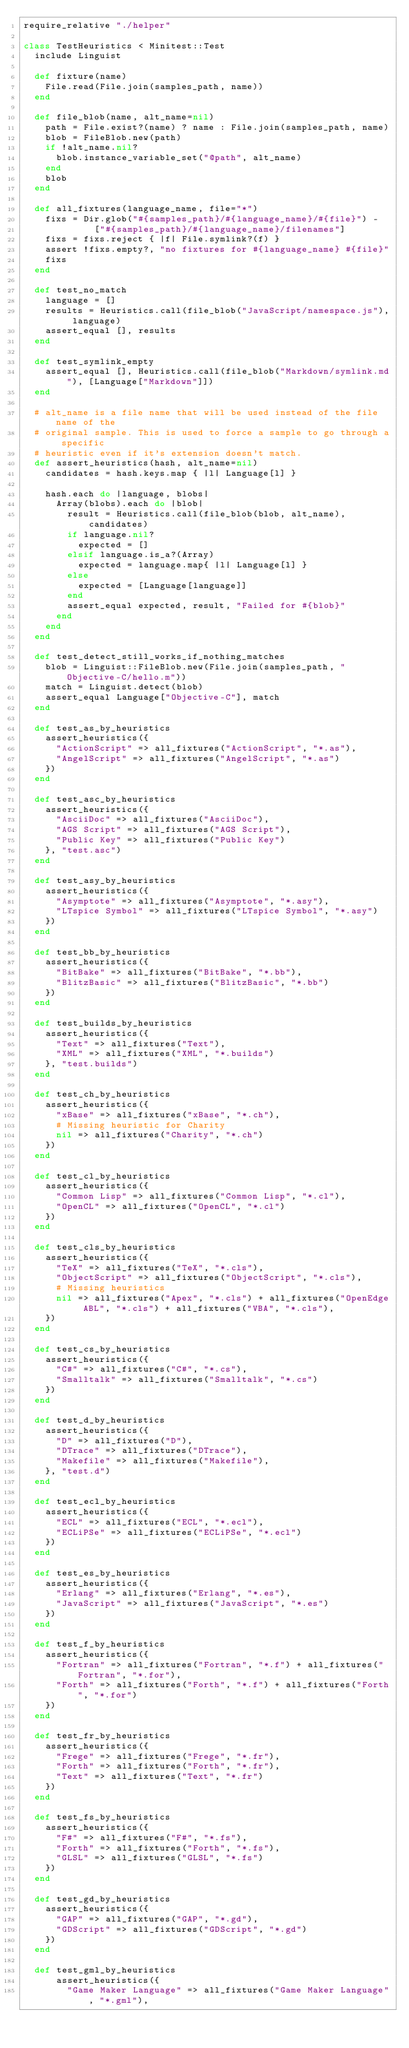Convert code to text. <code><loc_0><loc_0><loc_500><loc_500><_Ruby_>require_relative "./helper"

class TestHeuristics < Minitest::Test
  include Linguist

  def fixture(name)
    File.read(File.join(samples_path, name))
  end

  def file_blob(name, alt_name=nil)
    path = File.exist?(name) ? name : File.join(samples_path, name)
    blob = FileBlob.new(path)
    if !alt_name.nil?
      blob.instance_variable_set("@path", alt_name)
    end
    blob
  end

  def all_fixtures(language_name, file="*")
    fixs = Dir.glob("#{samples_path}/#{language_name}/#{file}") -
             ["#{samples_path}/#{language_name}/filenames"]
    fixs = fixs.reject { |f| File.symlink?(f) }
    assert !fixs.empty?, "no fixtures for #{language_name} #{file}"
    fixs
  end

  def test_no_match
    language = []
    results = Heuristics.call(file_blob("JavaScript/namespace.js"), language)
    assert_equal [], results
  end

  def test_symlink_empty
    assert_equal [], Heuristics.call(file_blob("Markdown/symlink.md"), [Language["Markdown"]])
  end

  # alt_name is a file name that will be used instead of the file name of the
  # original sample. This is used to force a sample to go through a specific
  # heuristic even if it's extension doesn't match.
  def assert_heuristics(hash, alt_name=nil)
    candidates = hash.keys.map { |l| Language[l] }

    hash.each do |language, blobs|
      Array(blobs).each do |blob|
        result = Heuristics.call(file_blob(blob, alt_name), candidates)
        if language.nil?
          expected = []
        elsif language.is_a?(Array)
          expected = language.map{ |l| Language[l] }
        else
          expected = [Language[language]]
        end
        assert_equal expected, result, "Failed for #{blob}"
      end
    end
  end

  def test_detect_still_works_if_nothing_matches
    blob = Linguist::FileBlob.new(File.join(samples_path, "Objective-C/hello.m"))
    match = Linguist.detect(blob)
    assert_equal Language["Objective-C"], match
  end

  def test_as_by_heuristics
    assert_heuristics({
      "ActionScript" => all_fixtures("ActionScript", "*.as"),
      "AngelScript" => all_fixtures("AngelScript", "*.as")
    })
  end

  def test_asc_by_heuristics
    assert_heuristics({
      "AsciiDoc" => all_fixtures("AsciiDoc"),
      "AGS Script" => all_fixtures("AGS Script"),
      "Public Key" => all_fixtures("Public Key")
    }, "test.asc")
  end

  def test_asy_by_heuristics
    assert_heuristics({
      "Asymptote" => all_fixtures("Asymptote", "*.asy"),
      "LTspice Symbol" => all_fixtures("LTspice Symbol", "*.asy")
    })
  end

  def test_bb_by_heuristics
    assert_heuristics({
      "BitBake" => all_fixtures("BitBake", "*.bb"),
      "BlitzBasic" => all_fixtures("BlitzBasic", "*.bb")
    })
  end

  def test_builds_by_heuristics
    assert_heuristics({
      "Text" => all_fixtures("Text"),
      "XML" => all_fixtures("XML", "*.builds")
    }, "test.builds")
  end

  def test_ch_by_heuristics
    assert_heuristics({
      "xBase" => all_fixtures("xBase", "*.ch"),
      # Missing heuristic for Charity
      nil => all_fixtures("Charity", "*.ch")
    })
  end

  def test_cl_by_heuristics
    assert_heuristics({
      "Common Lisp" => all_fixtures("Common Lisp", "*.cl"),
      "OpenCL" => all_fixtures("OpenCL", "*.cl")
    })
  end

  def test_cls_by_heuristics
    assert_heuristics({
      "TeX" => all_fixtures("TeX", "*.cls"),
      "ObjectScript" => all_fixtures("ObjectScript", "*.cls"),
      # Missing heuristics
      nil => all_fixtures("Apex", "*.cls") + all_fixtures("OpenEdge ABL", "*.cls") + all_fixtures("VBA", "*.cls"),
    })
  end

  def test_cs_by_heuristics
    assert_heuristics({
      "C#" => all_fixtures("C#", "*.cs"),
      "Smalltalk" => all_fixtures("Smalltalk", "*.cs")
    })
  end

  def test_d_by_heuristics
    assert_heuristics({
      "D" => all_fixtures("D"),
      "DTrace" => all_fixtures("DTrace"),
      "Makefile" => all_fixtures("Makefile"),
    }, "test.d")
  end

  def test_ecl_by_heuristics
    assert_heuristics({
      "ECL" => all_fixtures("ECL", "*.ecl"),
      "ECLiPSe" => all_fixtures("ECLiPSe", "*.ecl")
    })
  end

  def test_es_by_heuristics
    assert_heuristics({
      "Erlang" => all_fixtures("Erlang", "*.es"),
      "JavaScript" => all_fixtures("JavaScript", "*.es")
    })
  end

  def test_f_by_heuristics
    assert_heuristics({
      "Fortran" => all_fixtures("Fortran", "*.f") + all_fixtures("Fortran", "*.for"),
      "Forth" => all_fixtures("Forth", "*.f") + all_fixtures("Forth", "*.for")
    })
  end

  def test_fr_by_heuristics
    assert_heuristics({
      "Frege" => all_fixtures("Frege", "*.fr"),
      "Forth" => all_fixtures("Forth", "*.fr"),
      "Text" => all_fixtures("Text", "*.fr")
    })
  end

  def test_fs_by_heuristics
    assert_heuristics({
      "F#" => all_fixtures("F#", "*.fs"),
      "Forth" => all_fixtures("Forth", "*.fs"),
      "GLSL" => all_fixtures("GLSL", "*.fs")
    })
  end

  def test_gd_by_heuristics
    assert_heuristics({
      "GAP" => all_fixtures("GAP", "*.gd"),
      "GDScript" => all_fixtures("GDScript", "*.gd")
    })
  end

  def test_gml_by_heuristics
      assert_heuristics({
        "Game Maker Language" => all_fixtures("Game Maker Language", "*.gml"),</code> 